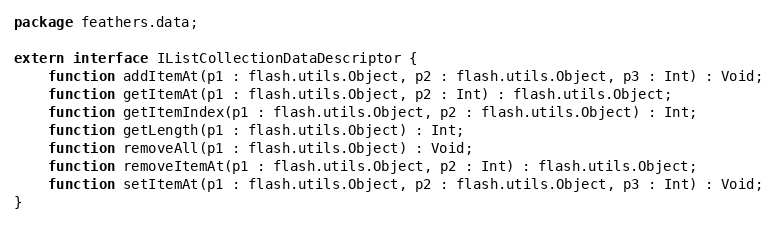<code> <loc_0><loc_0><loc_500><loc_500><_Haxe_>package feathers.data;

extern interface IListCollectionDataDescriptor {
	function addItemAt(p1 : flash.utils.Object, p2 : flash.utils.Object, p3 : Int) : Void;
	function getItemAt(p1 : flash.utils.Object, p2 : Int) : flash.utils.Object;
	function getItemIndex(p1 : flash.utils.Object, p2 : flash.utils.Object) : Int;
	function getLength(p1 : flash.utils.Object) : Int;
	function removeAll(p1 : flash.utils.Object) : Void;
	function removeItemAt(p1 : flash.utils.Object, p2 : Int) : flash.utils.Object;
	function setItemAt(p1 : flash.utils.Object, p2 : flash.utils.Object, p3 : Int) : Void;
}
</code> 